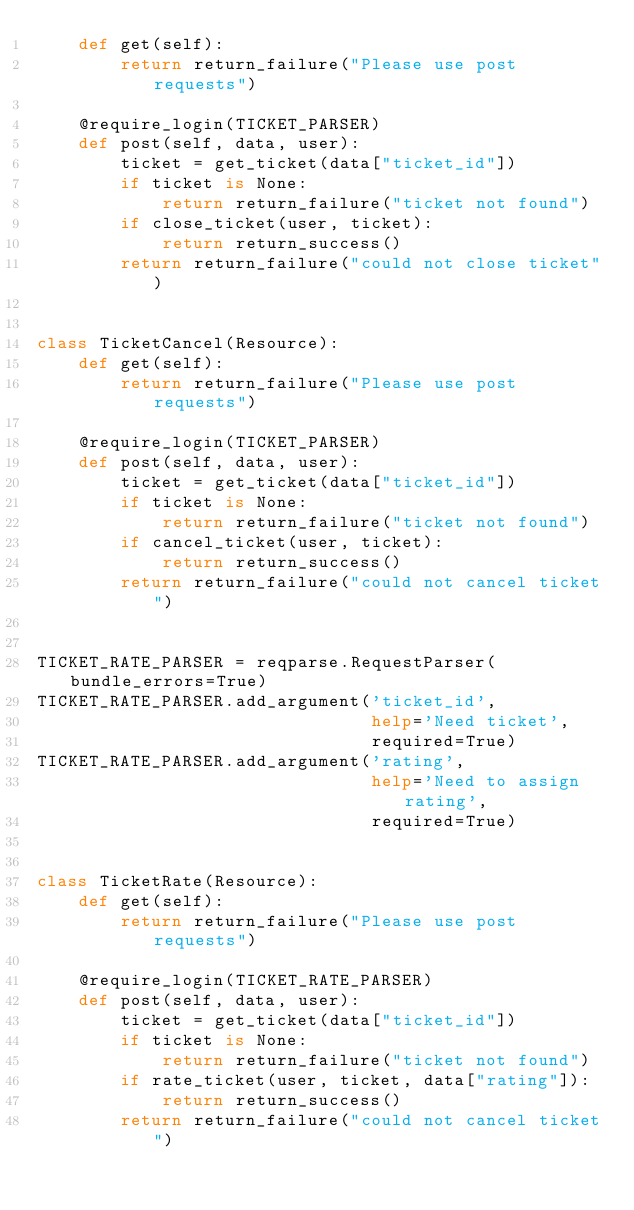<code> <loc_0><loc_0><loc_500><loc_500><_Python_>    def get(self):
        return return_failure("Please use post requests")

    @require_login(TICKET_PARSER)
    def post(self, data, user):
        ticket = get_ticket(data["ticket_id"])
        if ticket is None:
            return return_failure("ticket not found")
        if close_ticket(user, ticket):
            return return_success()
        return return_failure("could not close ticket")


class TicketCancel(Resource):
    def get(self):
        return return_failure("Please use post requests")

    @require_login(TICKET_PARSER)
    def post(self, data, user):
        ticket = get_ticket(data["ticket_id"])
        if ticket is None:
            return return_failure("ticket not found")
        if cancel_ticket(user, ticket):
            return return_success()
        return return_failure("could not cancel ticket")


TICKET_RATE_PARSER = reqparse.RequestParser(bundle_errors=True)
TICKET_RATE_PARSER.add_argument('ticket_id',
                                help='Need ticket',
                                required=True)
TICKET_RATE_PARSER.add_argument('rating',
                                help='Need to assign rating',
                                required=True)


class TicketRate(Resource):
    def get(self):
        return return_failure("Please use post requests")

    @require_login(TICKET_RATE_PARSER)
    def post(self, data, user):
        ticket = get_ticket(data["ticket_id"])
        if ticket is None:
            return return_failure("ticket not found")
        if rate_ticket(user, ticket, data["rating"]):
            return return_success()
        return return_failure("could not cancel ticket")
</code> 